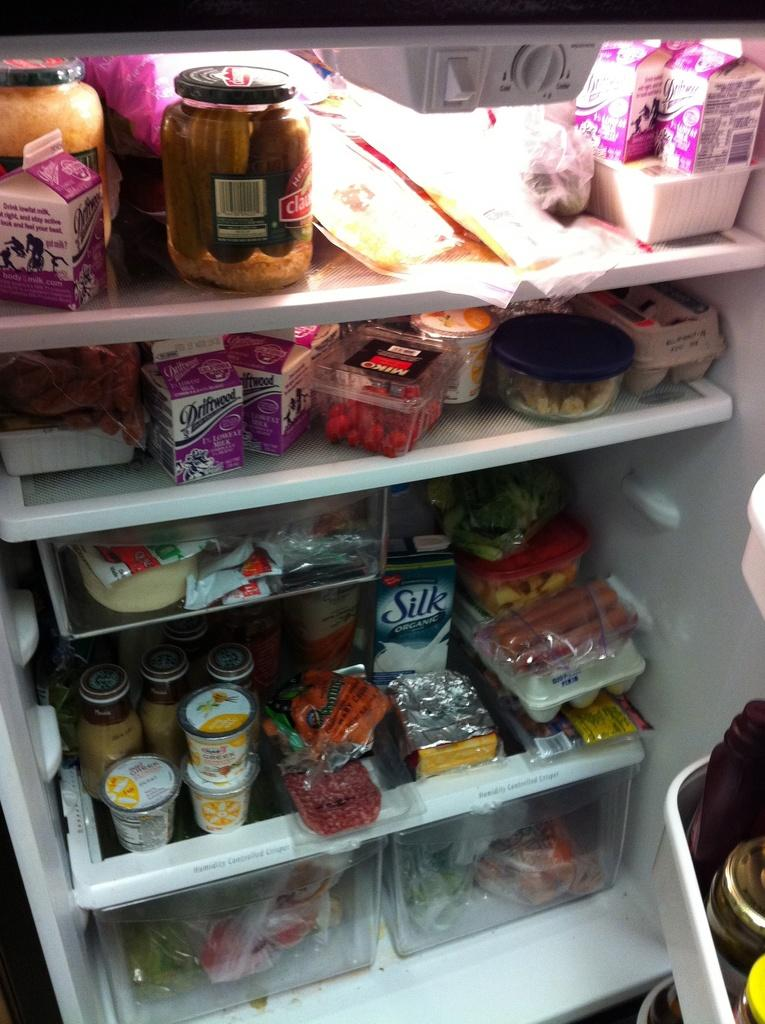<image>
Render a clear and concise summary of the photo. an interior of a fridge with items like Silk inside it 